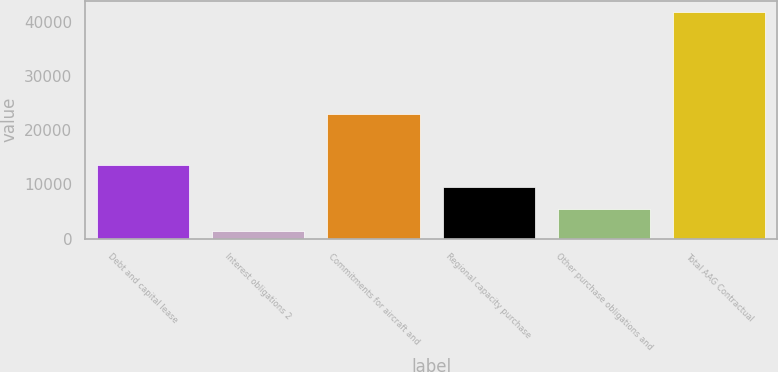Convert chart. <chart><loc_0><loc_0><loc_500><loc_500><bar_chart><fcel>Debt and capital lease<fcel>Interest obligations 2<fcel>Commitments for aircraft and<fcel>Regional capacity purchase<fcel>Other purchase obligations and<fcel>Total AAG Contractual<nl><fcel>13508.7<fcel>1392<fcel>23010<fcel>9469.8<fcel>5430.9<fcel>41781<nl></chart> 